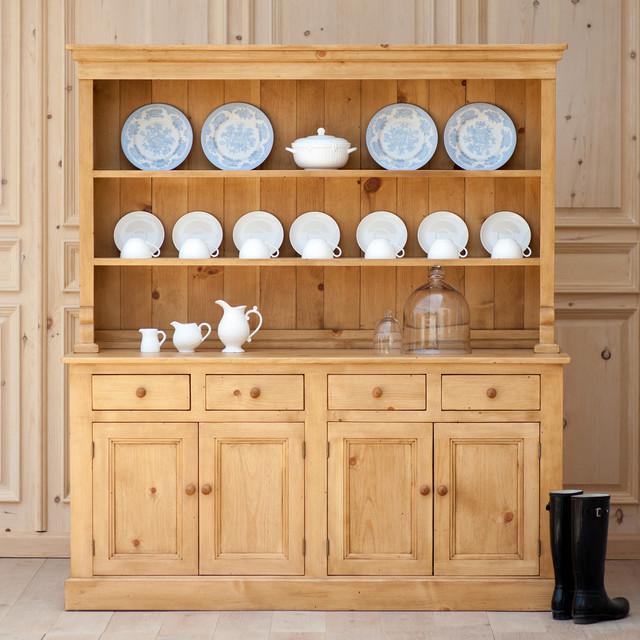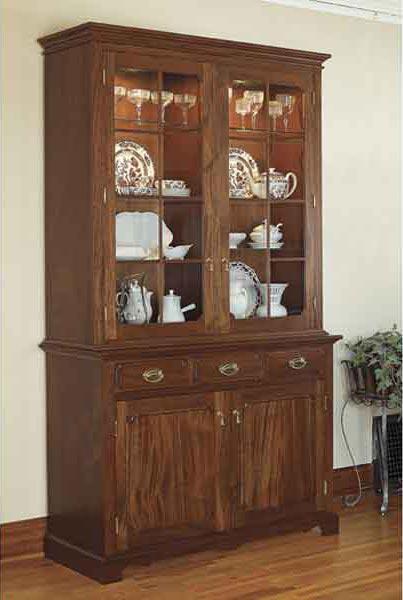The first image is the image on the left, the second image is the image on the right. Given the left and right images, does the statement "A richly-colored brown cabinet has an arch shape at the center of the top and sits flush on the floor." hold true? Answer yes or no. No. The first image is the image on the left, the second image is the image on the right. Examine the images to the left and right. Is the description "There is at least one chair in every image." accurate? Answer yes or no. No. 